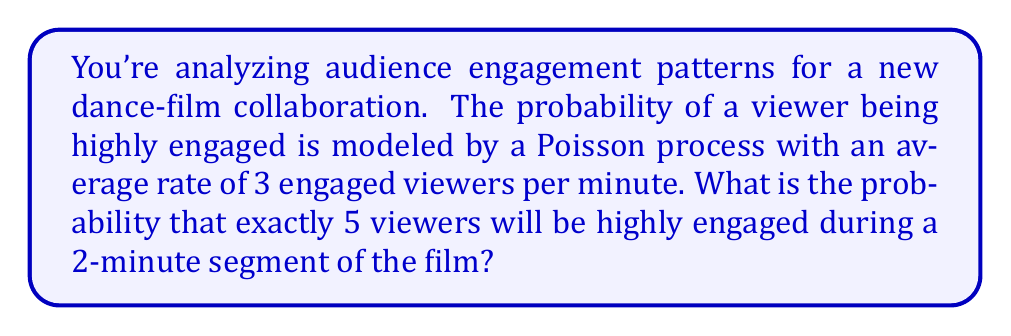Teach me how to tackle this problem. Let's approach this step-by-step:

1) We're dealing with a Poisson process, where:
   - λ (lambda) = average rate of occurrence
   - t = time interval
   - k = number of occurrences we're interested in

2) Given:
   - λ = 3 engaged viewers per minute
   - t = 2 minutes
   - k = 5 viewers

3) For a Poisson process, we need to calculate λt:
   λt = 3 * 2 = 6

4) The probability of exactly k occurrences in a Poisson process is given by the formula:

   $$P(X = k) = \frac{e^{-λt}(λt)^k}{k!}$$

5) Substituting our values:

   $$P(X = 5) = \frac{e^{-6}(6)^5}{5!}$$

6) Let's calculate this step-by-step:
   
   $$P(X = 5) = \frac{e^{-6} * 7776}{120}$$

7) Using a calculator:
   
   $$P(X = 5) ≈ 0.16062$$

8) Converting to a percentage:
   
   0.16062 * 100 ≈ 16.06%

Therefore, the probability of exactly 5 viewers being highly engaged during a 2-minute segment is approximately 16.06%.
Answer: 16.06% 